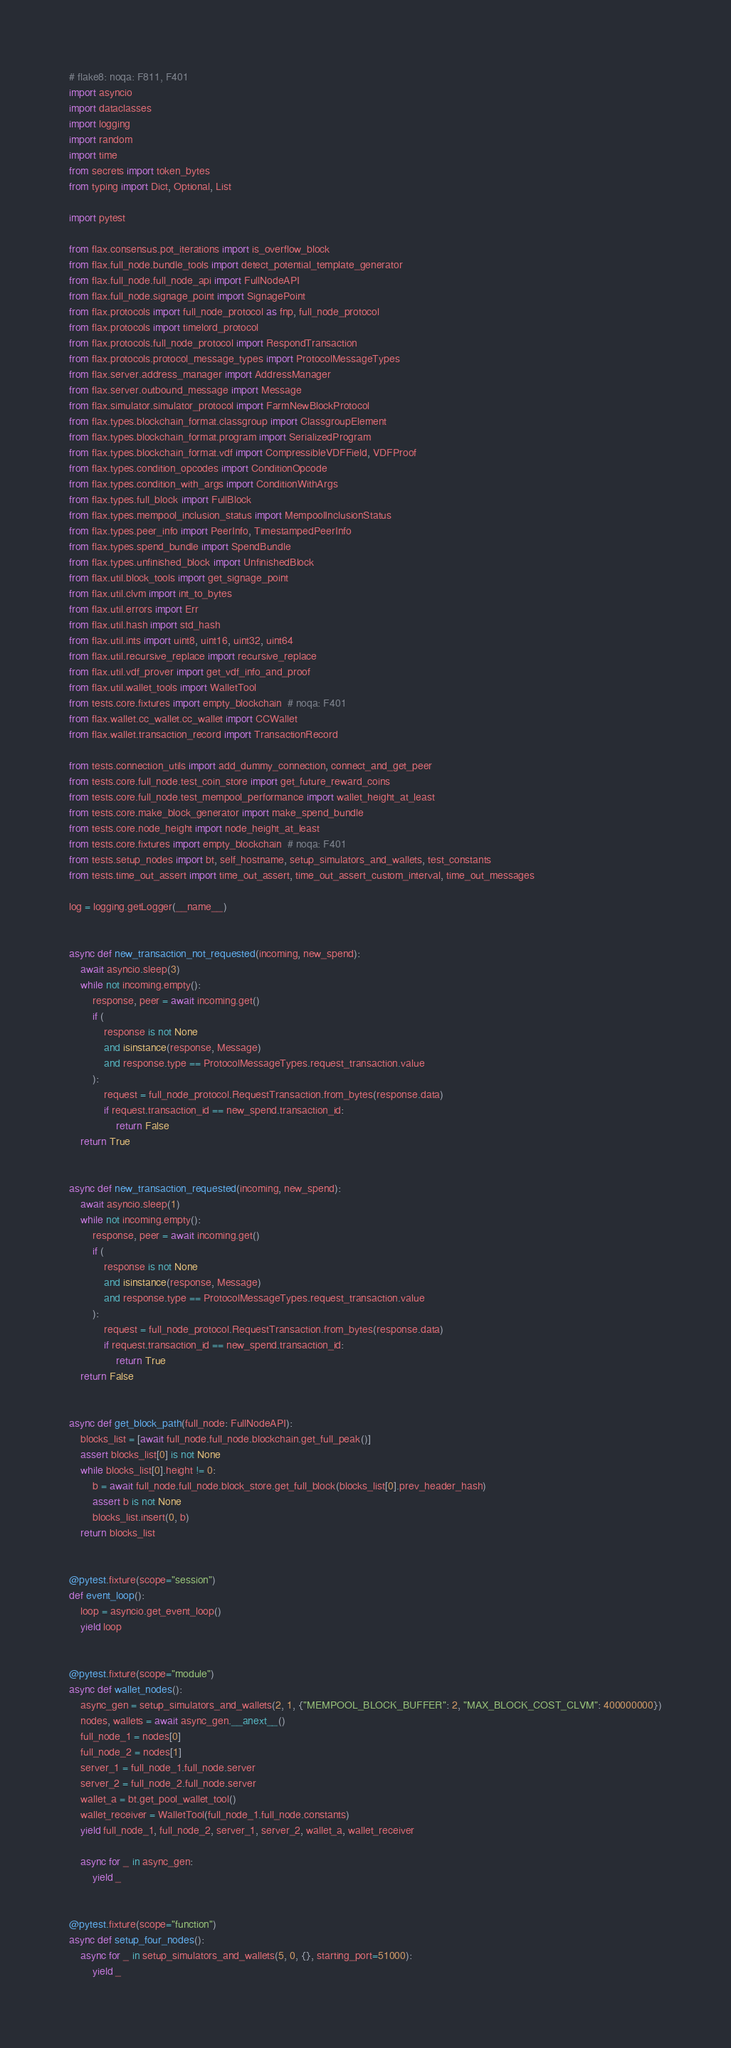<code> <loc_0><loc_0><loc_500><loc_500><_Python_># flake8: noqa: F811, F401
import asyncio
import dataclasses
import logging
import random
import time
from secrets import token_bytes
from typing import Dict, Optional, List

import pytest

from flax.consensus.pot_iterations import is_overflow_block
from flax.full_node.bundle_tools import detect_potential_template_generator
from flax.full_node.full_node_api import FullNodeAPI
from flax.full_node.signage_point import SignagePoint
from flax.protocols import full_node_protocol as fnp, full_node_protocol
from flax.protocols import timelord_protocol
from flax.protocols.full_node_protocol import RespondTransaction
from flax.protocols.protocol_message_types import ProtocolMessageTypes
from flax.server.address_manager import AddressManager
from flax.server.outbound_message import Message
from flax.simulator.simulator_protocol import FarmNewBlockProtocol
from flax.types.blockchain_format.classgroup import ClassgroupElement
from flax.types.blockchain_format.program import SerializedProgram
from flax.types.blockchain_format.vdf import CompressibleVDFField, VDFProof
from flax.types.condition_opcodes import ConditionOpcode
from flax.types.condition_with_args import ConditionWithArgs
from flax.types.full_block import FullBlock
from flax.types.mempool_inclusion_status import MempoolInclusionStatus
from flax.types.peer_info import PeerInfo, TimestampedPeerInfo
from flax.types.spend_bundle import SpendBundle
from flax.types.unfinished_block import UnfinishedBlock
from flax.util.block_tools import get_signage_point
from flax.util.clvm import int_to_bytes
from flax.util.errors import Err
from flax.util.hash import std_hash
from flax.util.ints import uint8, uint16, uint32, uint64
from flax.util.recursive_replace import recursive_replace
from flax.util.vdf_prover import get_vdf_info_and_proof
from flax.util.wallet_tools import WalletTool
from tests.core.fixtures import empty_blockchain  # noqa: F401
from flax.wallet.cc_wallet.cc_wallet import CCWallet
from flax.wallet.transaction_record import TransactionRecord

from tests.connection_utils import add_dummy_connection, connect_and_get_peer
from tests.core.full_node.test_coin_store import get_future_reward_coins
from tests.core.full_node.test_mempool_performance import wallet_height_at_least
from tests.core.make_block_generator import make_spend_bundle
from tests.core.node_height import node_height_at_least
from tests.core.fixtures import empty_blockchain  # noqa: F401
from tests.setup_nodes import bt, self_hostname, setup_simulators_and_wallets, test_constants
from tests.time_out_assert import time_out_assert, time_out_assert_custom_interval, time_out_messages

log = logging.getLogger(__name__)


async def new_transaction_not_requested(incoming, new_spend):
    await asyncio.sleep(3)
    while not incoming.empty():
        response, peer = await incoming.get()
        if (
            response is not None
            and isinstance(response, Message)
            and response.type == ProtocolMessageTypes.request_transaction.value
        ):
            request = full_node_protocol.RequestTransaction.from_bytes(response.data)
            if request.transaction_id == new_spend.transaction_id:
                return False
    return True


async def new_transaction_requested(incoming, new_spend):
    await asyncio.sleep(1)
    while not incoming.empty():
        response, peer = await incoming.get()
        if (
            response is not None
            and isinstance(response, Message)
            and response.type == ProtocolMessageTypes.request_transaction.value
        ):
            request = full_node_protocol.RequestTransaction.from_bytes(response.data)
            if request.transaction_id == new_spend.transaction_id:
                return True
    return False


async def get_block_path(full_node: FullNodeAPI):
    blocks_list = [await full_node.full_node.blockchain.get_full_peak()]
    assert blocks_list[0] is not None
    while blocks_list[0].height != 0:
        b = await full_node.full_node.block_store.get_full_block(blocks_list[0].prev_header_hash)
        assert b is not None
        blocks_list.insert(0, b)
    return blocks_list


@pytest.fixture(scope="session")
def event_loop():
    loop = asyncio.get_event_loop()
    yield loop


@pytest.fixture(scope="module")
async def wallet_nodes():
    async_gen = setup_simulators_and_wallets(2, 1, {"MEMPOOL_BLOCK_BUFFER": 2, "MAX_BLOCK_COST_CLVM": 400000000})
    nodes, wallets = await async_gen.__anext__()
    full_node_1 = nodes[0]
    full_node_2 = nodes[1]
    server_1 = full_node_1.full_node.server
    server_2 = full_node_2.full_node.server
    wallet_a = bt.get_pool_wallet_tool()
    wallet_receiver = WalletTool(full_node_1.full_node.constants)
    yield full_node_1, full_node_2, server_1, server_2, wallet_a, wallet_receiver

    async for _ in async_gen:
        yield _


@pytest.fixture(scope="function")
async def setup_four_nodes():
    async for _ in setup_simulators_and_wallets(5, 0, {}, starting_port=51000):
        yield _

</code> 